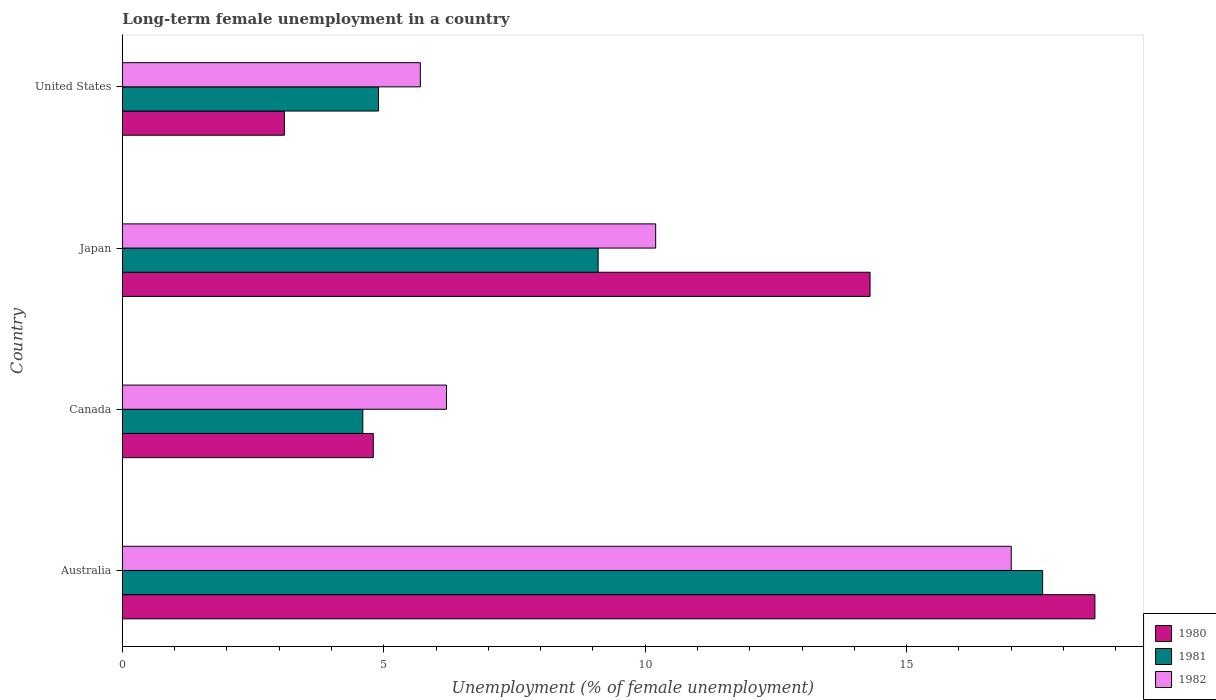How many groups of bars are there?
Provide a short and direct response. 4. Are the number of bars per tick equal to the number of legend labels?
Offer a terse response. Yes. Are the number of bars on each tick of the Y-axis equal?
Ensure brevity in your answer.  Yes. How many bars are there on the 1st tick from the bottom?
Provide a short and direct response. 3. What is the label of the 3rd group of bars from the top?
Offer a very short reply. Canada. In how many cases, is the number of bars for a given country not equal to the number of legend labels?
Your answer should be very brief. 0. What is the percentage of long-term unemployed female population in 1981 in Japan?
Provide a short and direct response. 9.1. Across all countries, what is the maximum percentage of long-term unemployed female population in 1980?
Offer a terse response. 18.6. Across all countries, what is the minimum percentage of long-term unemployed female population in 1981?
Make the answer very short. 4.6. In which country was the percentage of long-term unemployed female population in 1980 minimum?
Keep it short and to the point. United States. What is the total percentage of long-term unemployed female population in 1982 in the graph?
Give a very brief answer. 39.1. What is the difference between the percentage of long-term unemployed female population in 1982 in Canada and that in United States?
Keep it short and to the point. 0.5. What is the difference between the percentage of long-term unemployed female population in 1981 in United States and the percentage of long-term unemployed female population in 1982 in Australia?
Provide a short and direct response. -12.1. What is the average percentage of long-term unemployed female population in 1982 per country?
Keep it short and to the point. 9.77. What is the difference between the percentage of long-term unemployed female population in 1980 and percentage of long-term unemployed female population in 1981 in Japan?
Keep it short and to the point. 5.2. In how many countries, is the percentage of long-term unemployed female population in 1981 greater than 15 %?
Ensure brevity in your answer.  1. What is the ratio of the percentage of long-term unemployed female population in 1981 in Australia to that in United States?
Give a very brief answer. 3.59. Is the percentage of long-term unemployed female population in 1982 in Australia less than that in Japan?
Offer a terse response. No. Is the difference between the percentage of long-term unemployed female population in 1980 in Australia and Japan greater than the difference between the percentage of long-term unemployed female population in 1981 in Australia and Japan?
Make the answer very short. No. What is the difference between the highest and the second highest percentage of long-term unemployed female population in 1981?
Your answer should be very brief. 8.5. What is the difference between the highest and the lowest percentage of long-term unemployed female population in 1982?
Keep it short and to the point. 11.3. Is the sum of the percentage of long-term unemployed female population in 1981 in Japan and United States greater than the maximum percentage of long-term unemployed female population in 1982 across all countries?
Provide a succinct answer. No. How many bars are there?
Your answer should be compact. 12. Are all the bars in the graph horizontal?
Give a very brief answer. Yes. Are the values on the major ticks of X-axis written in scientific E-notation?
Your answer should be very brief. No. Does the graph contain grids?
Offer a very short reply. No. How many legend labels are there?
Provide a succinct answer. 3. What is the title of the graph?
Your response must be concise. Long-term female unemployment in a country. What is the label or title of the X-axis?
Provide a succinct answer. Unemployment (% of female unemployment). What is the label or title of the Y-axis?
Your answer should be compact. Country. What is the Unemployment (% of female unemployment) in 1980 in Australia?
Offer a terse response. 18.6. What is the Unemployment (% of female unemployment) of 1981 in Australia?
Your response must be concise. 17.6. What is the Unemployment (% of female unemployment) in 1982 in Australia?
Offer a very short reply. 17. What is the Unemployment (% of female unemployment) of 1980 in Canada?
Provide a short and direct response. 4.8. What is the Unemployment (% of female unemployment) of 1981 in Canada?
Your response must be concise. 4.6. What is the Unemployment (% of female unemployment) of 1982 in Canada?
Provide a short and direct response. 6.2. What is the Unemployment (% of female unemployment) of 1980 in Japan?
Your answer should be compact. 14.3. What is the Unemployment (% of female unemployment) of 1981 in Japan?
Offer a very short reply. 9.1. What is the Unemployment (% of female unemployment) of 1982 in Japan?
Ensure brevity in your answer.  10.2. What is the Unemployment (% of female unemployment) of 1980 in United States?
Your response must be concise. 3.1. What is the Unemployment (% of female unemployment) of 1981 in United States?
Give a very brief answer. 4.9. What is the Unemployment (% of female unemployment) in 1982 in United States?
Provide a short and direct response. 5.7. Across all countries, what is the maximum Unemployment (% of female unemployment) in 1980?
Offer a very short reply. 18.6. Across all countries, what is the maximum Unemployment (% of female unemployment) in 1981?
Offer a very short reply. 17.6. Across all countries, what is the maximum Unemployment (% of female unemployment) in 1982?
Your answer should be very brief. 17. Across all countries, what is the minimum Unemployment (% of female unemployment) of 1980?
Your answer should be very brief. 3.1. Across all countries, what is the minimum Unemployment (% of female unemployment) in 1981?
Your response must be concise. 4.6. Across all countries, what is the minimum Unemployment (% of female unemployment) in 1982?
Make the answer very short. 5.7. What is the total Unemployment (% of female unemployment) of 1980 in the graph?
Your answer should be very brief. 40.8. What is the total Unemployment (% of female unemployment) in 1981 in the graph?
Ensure brevity in your answer.  36.2. What is the total Unemployment (% of female unemployment) in 1982 in the graph?
Your answer should be compact. 39.1. What is the difference between the Unemployment (% of female unemployment) of 1982 in Australia and that in Japan?
Keep it short and to the point. 6.8. What is the difference between the Unemployment (% of female unemployment) of 1980 in Australia and that in United States?
Provide a short and direct response. 15.5. What is the difference between the Unemployment (% of female unemployment) in 1981 in Australia and that in United States?
Make the answer very short. 12.7. What is the difference between the Unemployment (% of female unemployment) in 1982 in Australia and that in United States?
Provide a succinct answer. 11.3. What is the difference between the Unemployment (% of female unemployment) in 1980 in Canada and that in Japan?
Your answer should be compact. -9.5. What is the difference between the Unemployment (% of female unemployment) in 1980 in Canada and that in United States?
Your answer should be very brief. 1.7. What is the difference between the Unemployment (% of female unemployment) of 1981 in Canada and that in United States?
Your response must be concise. -0.3. What is the difference between the Unemployment (% of female unemployment) of 1980 in Australia and the Unemployment (% of female unemployment) of 1981 in Canada?
Your response must be concise. 14. What is the difference between the Unemployment (% of female unemployment) in 1980 in Australia and the Unemployment (% of female unemployment) in 1982 in Canada?
Ensure brevity in your answer.  12.4. What is the difference between the Unemployment (% of female unemployment) in 1980 in Australia and the Unemployment (% of female unemployment) in 1981 in Japan?
Ensure brevity in your answer.  9.5. What is the difference between the Unemployment (% of female unemployment) in 1980 in Australia and the Unemployment (% of female unemployment) in 1982 in United States?
Offer a very short reply. 12.9. What is the difference between the Unemployment (% of female unemployment) in 1981 in Australia and the Unemployment (% of female unemployment) in 1982 in United States?
Provide a short and direct response. 11.9. What is the difference between the Unemployment (% of female unemployment) in 1981 in Canada and the Unemployment (% of female unemployment) in 1982 in Japan?
Make the answer very short. -5.6. What is the difference between the Unemployment (% of female unemployment) of 1980 in Canada and the Unemployment (% of female unemployment) of 1981 in United States?
Your response must be concise. -0.1. What is the difference between the Unemployment (% of female unemployment) of 1980 in Canada and the Unemployment (% of female unemployment) of 1982 in United States?
Offer a terse response. -0.9. What is the difference between the Unemployment (% of female unemployment) in 1981 in Canada and the Unemployment (% of female unemployment) in 1982 in United States?
Give a very brief answer. -1.1. What is the difference between the Unemployment (% of female unemployment) in 1980 in Japan and the Unemployment (% of female unemployment) in 1981 in United States?
Ensure brevity in your answer.  9.4. What is the difference between the Unemployment (% of female unemployment) in 1981 in Japan and the Unemployment (% of female unemployment) in 1982 in United States?
Provide a short and direct response. 3.4. What is the average Unemployment (% of female unemployment) of 1980 per country?
Offer a very short reply. 10.2. What is the average Unemployment (% of female unemployment) of 1981 per country?
Give a very brief answer. 9.05. What is the average Unemployment (% of female unemployment) in 1982 per country?
Keep it short and to the point. 9.78. What is the difference between the Unemployment (% of female unemployment) in 1980 and Unemployment (% of female unemployment) in 1981 in Australia?
Ensure brevity in your answer.  1. What is the difference between the Unemployment (% of female unemployment) in 1981 and Unemployment (% of female unemployment) in 1982 in Australia?
Make the answer very short. 0.6. What is the difference between the Unemployment (% of female unemployment) in 1980 and Unemployment (% of female unemployment) in 1982 in Canada?
Make the answer very short. -1.4. What is the difference between the Unemployment (% of female unemployment) in 1980 and Unemployment (% of female unemployment) in 1981 in United States?
Keep it short and to the point. -1.8. What is the difference between the Unemployment (% of female unemployment) in 1980 and Unemployment (% of female unemployment) in 1982 in United States?
Provide a short and direct response. -2.6. What is the difference between the Unemployment (% of female unemployment) in 1981 and Unemployment (% of female unemployment) in 1982 in United States?
Offer a terse response. -0.8. What is the ratio of the Unemployment (% of female unemployment) in 1980 in Australia to that in Canada?
Your answer should be compact. 3.88. What is the ratio of the Unemployment (% of female unemployment) of 1981 in Australia to that in Canada?
Provide a short and direct response. 3.83. What is the ratio of the Unemployment (% of female unemployment) in 1982 in Australia to that in Canada?
Provide a succinct answer. 2.74. What is the ratio of the Unemployment (% of female unemployment) in 1980 in Australia to that in Japan?
Your answer should be compact. 1.3. What is the ratio of the Unemployment (% of female unemployment) in 1981 in Australia to that in Japan?
Ensure brevity in your answer.  1.93. What is the ratio of the Unemployment (% of female unemployment) in 1980 in Australia to that in United States?
Offer a very short reply. 6. What is the ratio of the Unemployment (% of female unemployment) of 1981 in Australia to that in United States?
Make the answer very short. 3.59. What is the ratio of the Unemployment (% of female unemployment) in 1982 in Australia to that in United States?
Your answer should be compact. 2.98. What is the ratio of the Unemployment (% of female unemployment) of 1980 in Canada to that in Japan?
Provide a short and direct response. 0.34. What is the ratio of the Unemployment (% of female unemployment) in 1981 in Canada to that in Japan?
Your answer should be very brief. 0.51. What is the ratio of the Unemployment (% of female unemployment) of 1982 in Canada to that in Japan?
Ensure brevity in your answer.  0.61. What is the ratio of the Unemployment (% of female unemployment) of 1980 in Canada to that in United States?
Your answer should be compact. 1.55. What is the ratio of the Unemployment (% of female unemployment) in 1981 in Canada to that in United States?
Give a very brief answer. 0.94. What is the ratio of the Unemployment (% of female unemployment) in 1982 in Canada to that in United States?
Make the answer very short. 1.09. What is the ratio of the Unemployment (% of female unemployment) of 1980 in Japan to that in United States?
Ensure brevity in your answer.  4.61. What is the ratio of the Unemployment (% of female unemployment) in 1981 in Japan to that in United States?
Give a very brief answer. 1.86. What is the ratio of the Unemployment (% of female unemployment) in 1982 in Japan to that in United States?
Give a very brief answer. 1.79. What is the difference between the highest and the lowest Unemployment (% of female unemployment) of 1981?
Provide a succinct answer. 13. What is the difference between the highest and the lowest Unemployment (% of female unemployment) in 1982?
Offer a terse response. 11.3. 